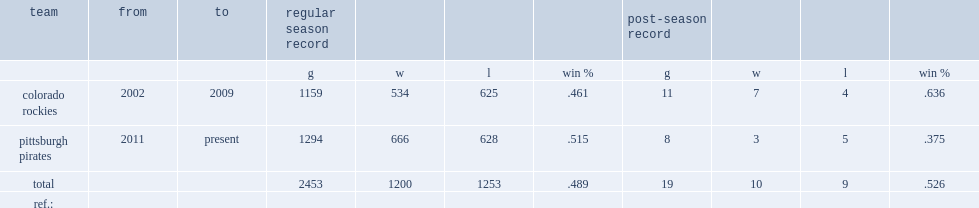What was the win-loss record of colorado rockies? 534.0 625.0. 